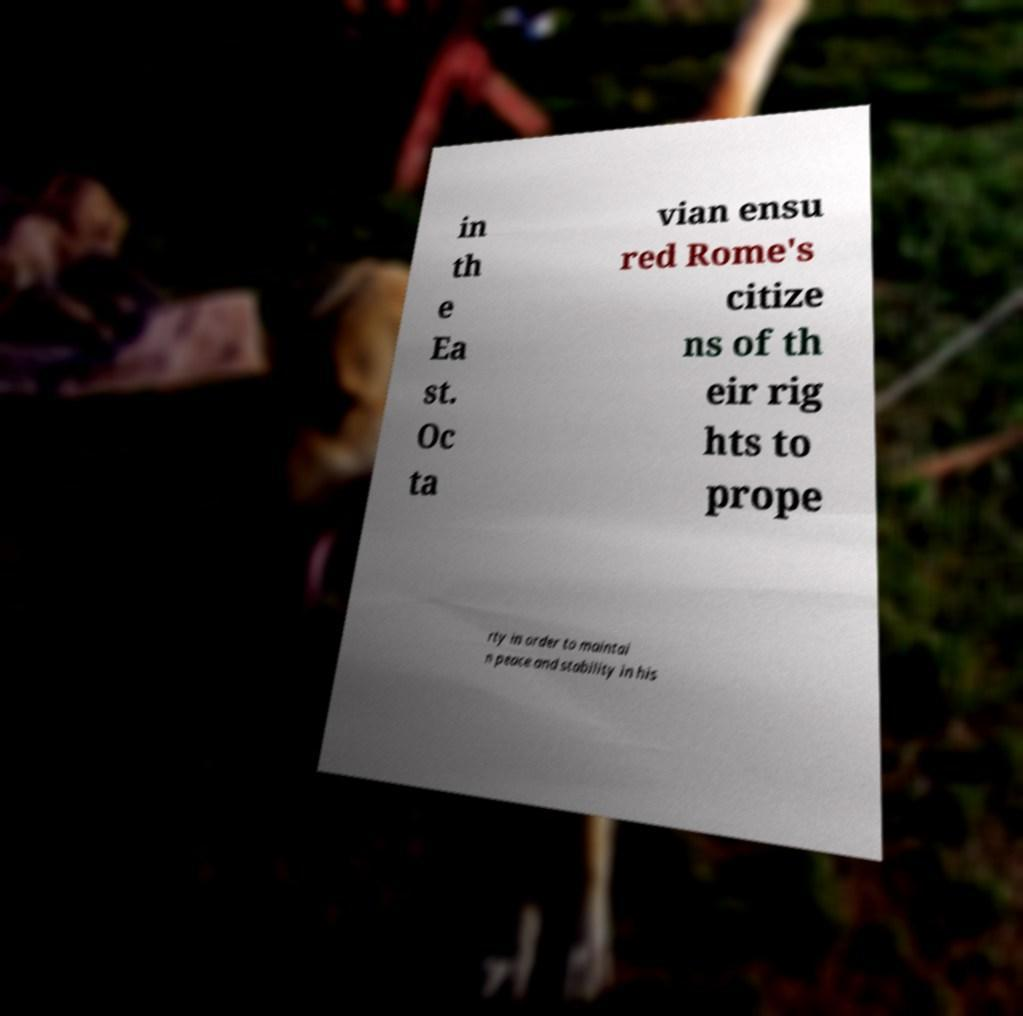For documentation purposes, I need the text within this image transcribed. Could you provide that? in th e Ea st. Oc ta vian ensu red Rome's citize ns of th eir rig hts to prope rty in order to maintai n peace and stability in his 